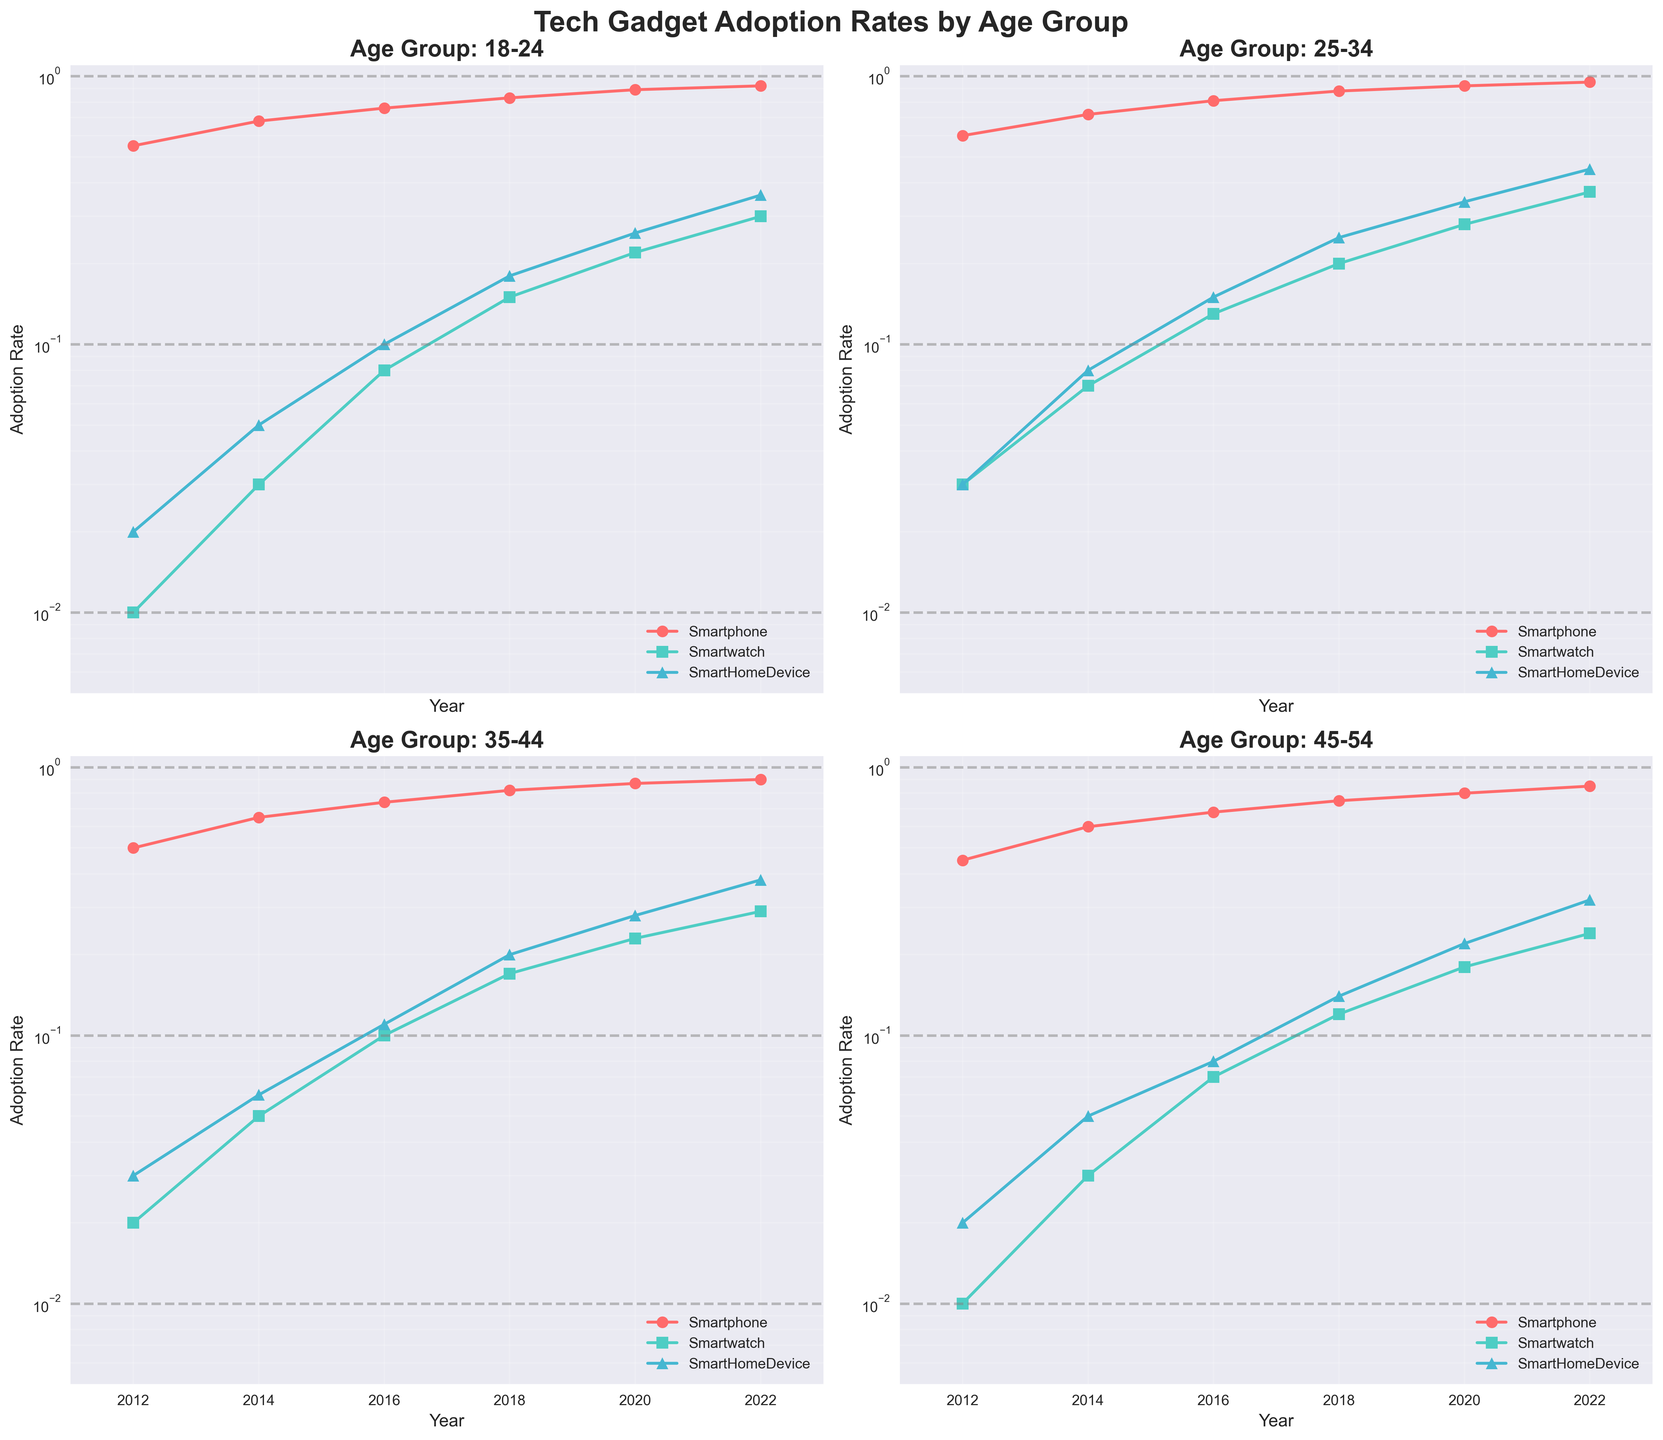What is the title of the figure? The title of the figure is displayed at the top and reads "Tech Gadget Adoption Rates by Age Group".
Answer: Tech Gadget Adoption Rates by Age Group Which gadget has had the highest adoption rate among the 18-24 age group in 2022? In the subplot labeled "Age Group: 18-24," the lines represent different gadgets. The gadget with the highest adoption rate in 2022 is indicated by the line that reaches the highest point on the y-axis at the year 2022, which is the smartphone.
Answer: Smartphone What is the adoption rate of smartwatches for the 45-54 age group in 2014? On the subplot labeled "Age Group: 45-54," locate the line representing smartwatches, then find the value for the year 2014. This value is approximately 0.03.
Answer: 0.03 Which age group had a higher adoption rate of smart home devices in 2020, 35-44 or 45-54? Compare the adoption rates for smart home devices in 2020 on the subplots for "Age Group: 35-44" and "Age Group: 45-54." The rate for 35-44 is about 0.28, whereas it’s about 0.22 for 45-54.
Answer: 35-44 Among all the age groups, which gadget shows the most rapid increase in adoption rate from 2012 to 2022? Observe the slopes of the lines for different gadgets across all subplots. The steepest line indicates the most rapid increase. Smartwatches, especially in younger age groups, show the most rapid increase in adoption rate over the decade.
Answer: Smartwatch In the 25-34 age group, how much did the adoption rate of smartphones increase from 2012 to 2022? On the subplot labeled "Age Group: 25-34," note the adoption rate for smartphones in 2012 (~0.60) and in 2022 (~0.95). Calculate the difference: 0.95 - 0.60 = 0.35.
Answer: 0.35 Which age group had the lowest adoption rate of smartwatches in 2018? On each subplot, find the line representing smartwatches and note the value at the year 2018. The 45-54 age group has the lowest adoption rate of smartwatches in 2018 at approximately 0.12.
Answer: 45-54 Do any age groups have a year where the adoption rates for smart home devices and smartwatches are approximately equal? Check each subplot to compare the lines for smart home devices and smartwatches over the years. In the 35-44 age group, around 2016, the adoption rates for both smart home devices and smartwatches are both around 0.11.
Answer: Yes, 35-44 in 2016 